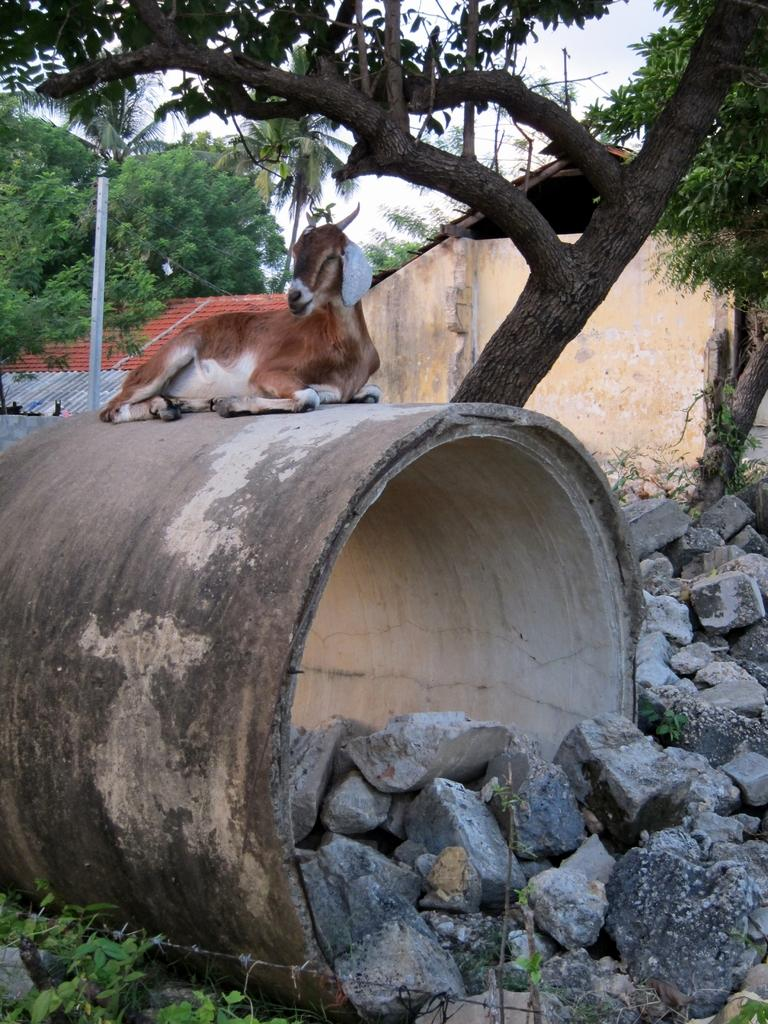What animal is present in the image? There is a goat in the image. What is the goat standing on? The goat is on an object that resembles a pipe. What type of natural elements can be seen in the image? There are stones, plants, and trees in the image. What type of man-made structures are visible in the background? There are buildings in the background of the image. What type of hospital is depicted in the image? There is no hospital present in the image; it features a goat on a pipe-like structure, surrounded by natural elements and buildings in the background. How many stamps are visible on the goat in the image? There are no stamps present on the goat or any other element in the image. 